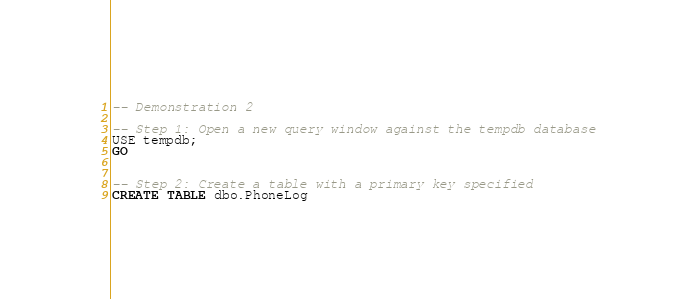Convert code to text. <code><loc_0><loc_0><loc_500><loc_500><_SQL_>-- Demonstration 2

-- Step 1: Open a new query window against the tempdb database
USE tempdb;
GO


-- Step 2: Create a table with a primary key specified
CREATE TABLE dbo.PhoneLog</code> 